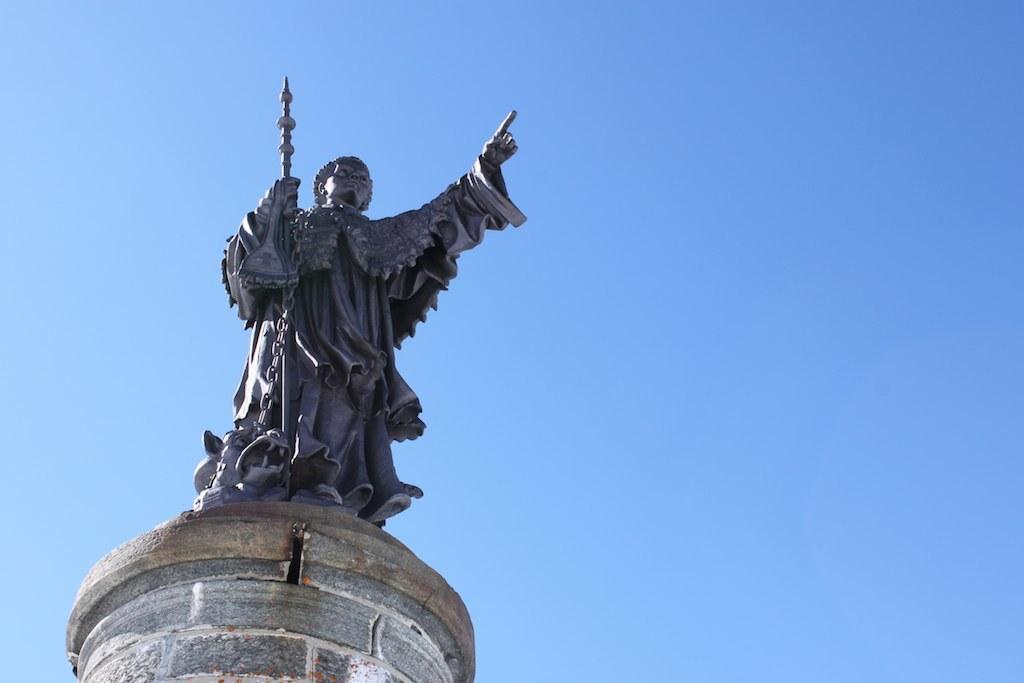Describe this image in one or two sentences. In this picture I can see there is a statue holding a object and in the backdrop the sky is clear. 